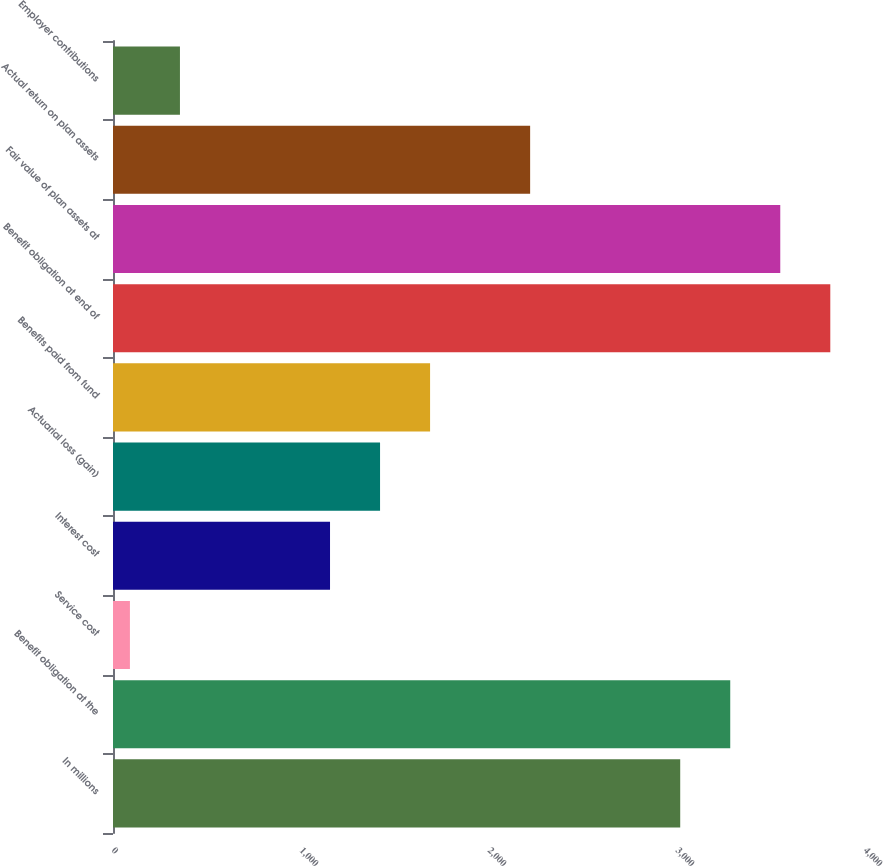Convert chart to OTSL. <chart><loc_0><loc_0><loc_500><loc_500><bar_chart><fcel>In millions<fcel>Benefit obligation at the<fcel>Service cost<fcel>Interest cost<fcel>Actuarial loss (gain)<fcel>Benefits paid from fund<fcel>Benefit obligation at end of<fcel>Fair value of plan assets at<fcel>Actual return on plan assets<fcel>Employer contributions<nl><fcel>3017.1<fcel>3283.2<fcel>90<fcel>1154.4<fcel>1420.5<fcel>1686.6<fcel>3815.4<fcel>3549.3<fcel>2218.8<fcel>356.1<nl></chart> 